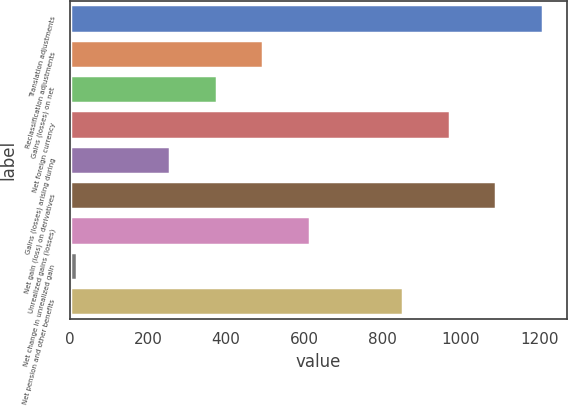Convert chart. <chart><loc_0><loc_0><loc_500><loc_500><bar_chart><fcel>Translation adjustments<fcel>Reclassification adjustments<fcel>Gains (losses) on net<fcel>Net foreign currency<fcel>Gains (losses) arising during<fcel>Net gain (loss) on derivatives<fcel>Unrealized gains (losses)<fcel>Net change in unrealized gain<fcel>Net pension and other benefits<nl><fcel>1210<fcel>495.4<fcel>376.3<fcel>971.8<fcel>257.2<fcel>1090.9<fcel>614.5<fcel>19<fcel>852.7<nl></chart> 